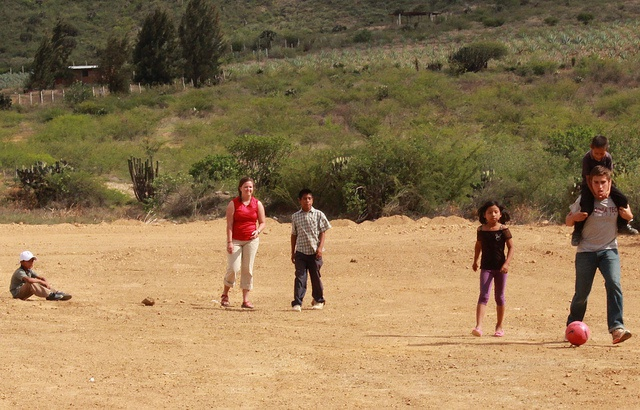Describe the objects in this image and their specific colors. I can see people in black, gray, and maroon tones, people in black, maroon, and tan tones, people in black, brown, maroon, and tan tones, people in black, gray, and maroon tones, and people in black, maroon, gray, and brown tones in this image. 